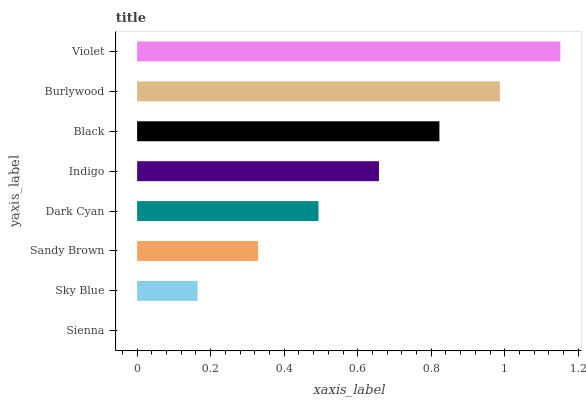Is Sienna the minimum?
Answer yes or no. Yes. Is Violet the maximum?
Answer yes or no. Yes. Is Sky Blue the minimum?
Answer yes or no. No. Is Sky Blue the maximum?
Answer yes or no. No. Is Sky Blue greater than Sienna?
Answer yes or no. Yes. Is Sienna less than Sky Blue?
Answer yes or no. Yes. Is Sienna greater than Sky Blue?
Answer yes or no. No. Is Sky Blue less than Sienna?
Answer yes or no. No. Is Indigo the high median?
Answer yes or no. Yes. Is Dark Cyan the low median?
Answer yes or no. Yes. Is Sandy Brown the high median?
Answer yes or no. No. Is Indigo the low median?
Answer yes or no. No. 